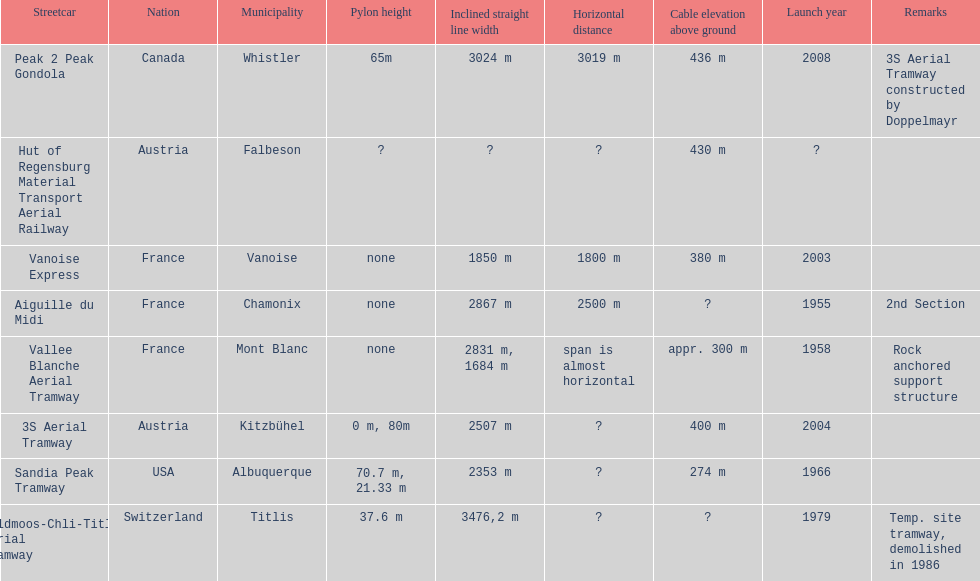How much greater is the height of cable over ground measurement for the peak 2 peak gondola when compared with that of the vanoise express? 56 m. 